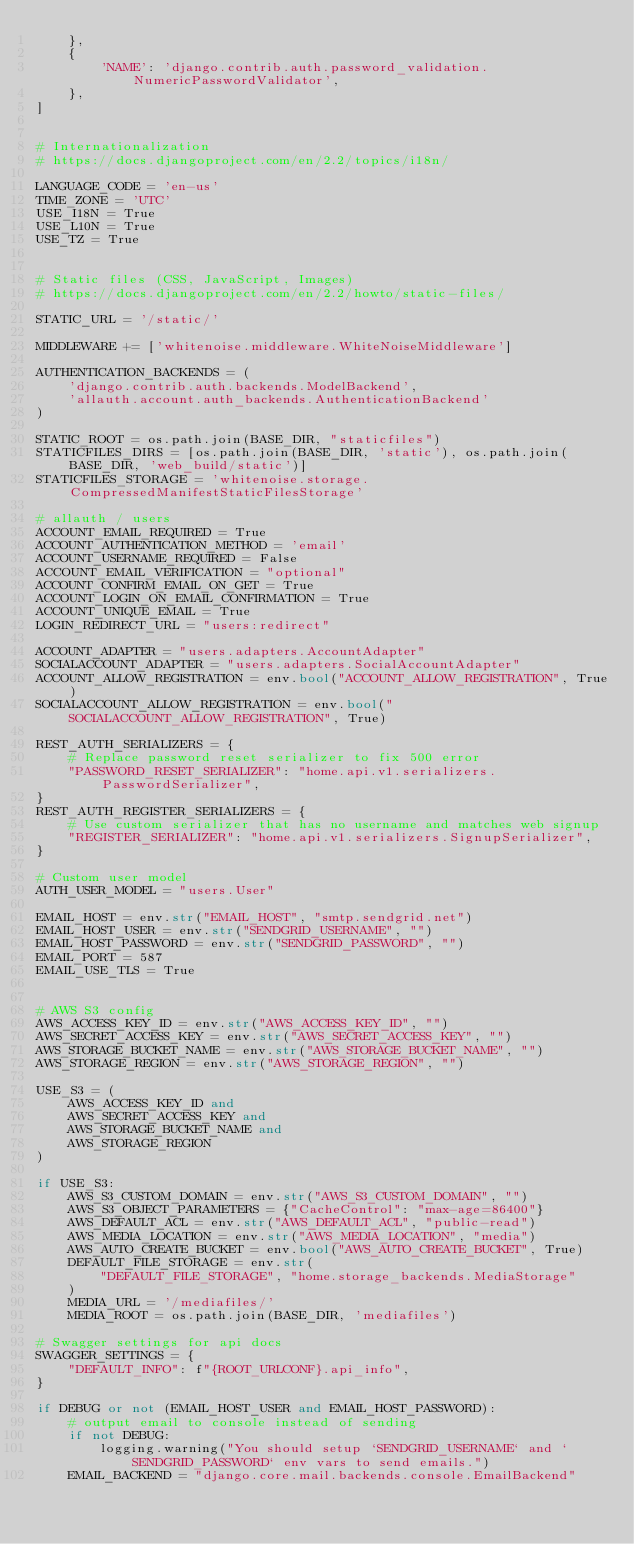Convert code to text. <code><loc_0><loc_0><loc_500><loc_500><_Python_>    },
    {
        'NAME': 'django.contrib.auth.password_validation.NumericPasswordValidator',
    },
]


# Internationalization
# https://docs.djangoproject.com/en/2.2/topics/i18n/

LANGUAGE_CODE = 'en-us'
TIME_ZONE = 'UTC'
USE_I18N = True
USE_L10N = True
USE_TZ = True


# Static files (CSS, JavaScript, Images)
# https://docs.djangoproject.com/en/2.2/howto/static-files/

STATIC_URL = '/static/'

MIDDLEWARE += ['whitenoise.middleware.WhiteNoiseMiddleware']

AUTHENTICATION_BACKENDS = (
    'django.contrib.auth.backends.ModelBackend',
    'allauth.account.auth_backends.AuthenticationBackend'
)

STATIC_ROOT = os.path.join(BASE_DIR, "staticfiles")
STATICFILES_DIRS = [os.path.join(BASE_DIR, 'static'), os.path.join(BASE_DIR, 'web_build/static')]
STATICFILES_STORAGE = 'whitenoise.storage.CompressedManifestStaticFilesStorage'

# allauth / users
ACCOUNT_EMAIL_REQUIRED = True
ACCOUNT_AUTHENTICATION_METHOD = 'email'
ACCOUNT_USERNAME_REQUIRED = False
ACCOUNT_EMAIL_VERIFICATION = "optional"
ACCOUNT_CONFIRM_EMAIL_ON_GET = True
ACCOUNT_LOGIN_ON_EMAIL_CONFIRMATION = True
ACCOUNT_UNIQUE_EMAIL = True
LOGIN_REDIRECT_URL = "users:redirect"

ACCOUNT_ADAPTER = "users.adapters.AccountAdapter"
SOCIALACCOUNT_ADAPTER = "users.adapters.SocialAccountAdapter"
ACCOUNT_ALLOW_REGISTRATION = env.bool("ACCOUNT_ALLOW_REGISTRATION", True)
SOCIALACCOUNT_ALLOW_REGISTRATION = env.bool("SOCIALACCOUNT_ALLOW_REGISTRATION", True)

REST_AUTH_SERIALIZERS = {
    # Replace password reset serializer to fix 500 error
    "PASSWORD_RESET_SERIALIZER": "home.api.v1.serializers.PasswordSerializer",
}
REST_AUTH_REGISTER_SERIALIZERS = {
    # Use custom serializer that has no username and matches web signup
    "REGISTER_SERIALIZER": "home.api.v1.serializers.SignupSerializer",
}

# Custom user model
AUTH_USER_MODEL = "users.User"

EMAIL_HOST = env.str("EMAIL_HOST", "smtp.sendgrid.net")
EMAIL_HOST_USER = env.str("SENDGRID_USERNAME", "")
EMAIL_HOST_PASSWORD = env.str("SENDGRID_PASSWORD", "")
EMAIL_PORT = 587
EMAIL_USE_TLS = True


# AWS S3 config
AWS_ACCESS_KEY_ID = env.str("AWS_ACCESS_KEY_ID", "")
AWS_SECRET_ACCESS_KEY = env.str("AWS_SECRET_ACCESS_KEY", "")
AWS_STORAGE_BUCKET_NAME = env.str("AWS_STORAGE_BUCKET_NAME", "")
AWS_STORAGE_REGION = env.str("AWS_STORAGE_REGION", "")

USE_S3 = (
    AWS_ACCESS_KEY_ID and
    AWS_SECRET_ACCESS_KEY and
    AWS_STORAGE_BUCKET_NAME and
    AWS_STORAGE_REGION
)

if USE_S3:
    AWS_S3_CUSTOM_DOMAIN = env.str("AWS_S3_CUSTOM_DOMAIN", "")
    AWS_S3_OBJECT_PARAMETERS = {"CacheControl": "max-age=86400"}
    AWS_DEFAULT_ACL = env.str("AWS_DEFAULT_ACL", "public-read")
    AWS_MEDIA_LOCATION = env.str("AWS_MEDIA_LOCATION", "media")
    AWS_AUTO_CREATE_BUCKET = env.bool("AWS_AUTO_CREATE_BUCKET", True)
    DEFAULT_FILE_STORAGE = env.str(
        "DEFAULT_FILE_STORAGE", "home.storage_backends.MediaStorage"
    )
    MEDIA_URL = '/mediafiles/'
    MEDIA_ROOT = os.path.join(BASE_DIR, 'mediafiles')

# Swagger settings for api docs
SWAGGER_SETTINGS = {
    "DEFAULT_INFO": f"{ROOT_URLCONF}.api_info",
}

if DEBUG or not (EMAIL_HOST_USER and EMAIL_HOST_PASSWORD):
    # output email to console instead of sending
    if not DEBUG:
        logging.warning("You should setup `SENDGRID_USERNAME` and `SENDGRID_PASSWORD` env vars to send emails.")
    EMAIL_BACKEND = "django.core.mail.backends.console.EmailBackend"
</code> 